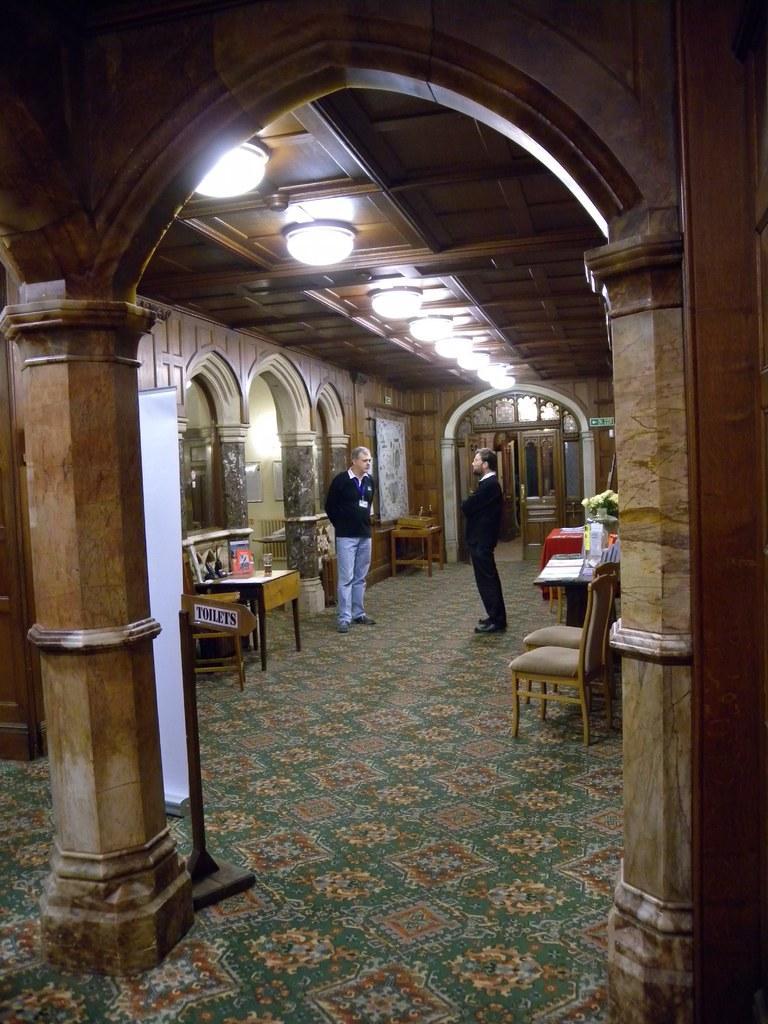Describe this image in one or two sentences. In this image there are two men standing, there are chairs, there are tables, there are objects on the tables, there is a board, there are pillars, there is a wall, there is a roof, there are lights. 